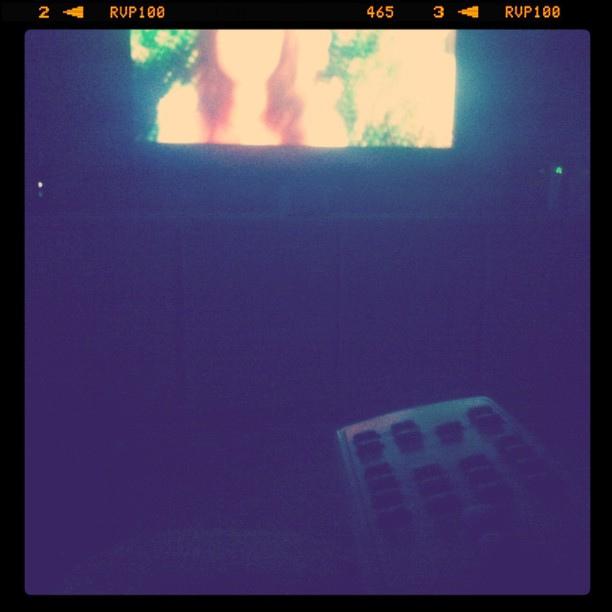Is this a high quality image?
Write a very short answer. No. What companion object to the TV can be seen in the bottom right of the picture?
Answer briefly. Remote. Is the TV on or off?
Be succinct. On. 